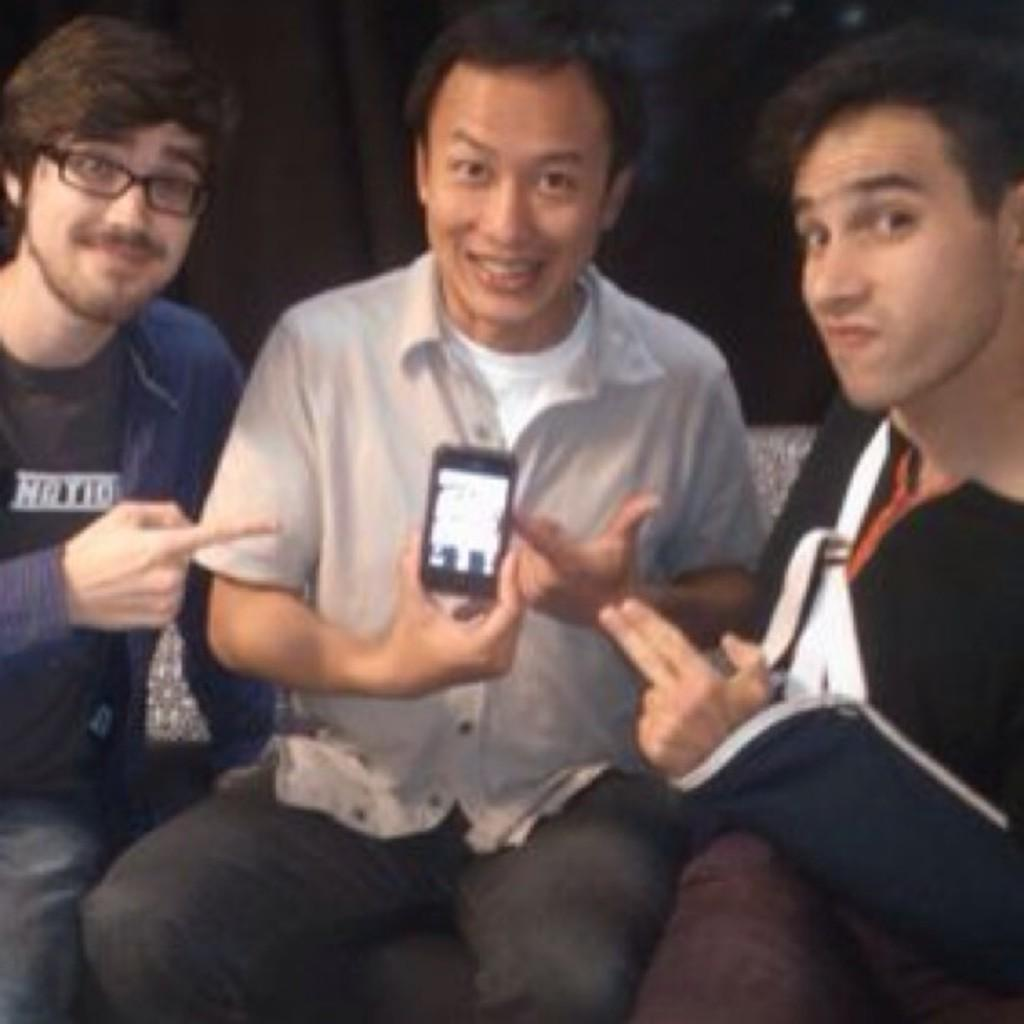How many people are in the image? There are three persons in the image. What are the persons doing in the image? The persons are sitting on a chair and smiling. Can you describe the appearance of the left person? The left person is wearing spectacles and holding a mobile phone. What word is the person on the right saying in the image? There is no indication in the image of what words the persons might be saying, as their mouths are not visible. --- Facts: 1. There is a car in the image. 2. The car is red. 3. The car has four wheels. 4. There is a road in the image. 5. The road is paved. Absurd Topics: bird, dance, ocean Conversation: What is the main subject of the image? The main subject of the image is a car. Can you describe the appearance of the car? The car is red and has four wheels. What is the surface of the road in the image? The road is paved. Reasoning: Let's think step by step in order to produce the conversation. We start by identifying the main subject of the image, which is the car. Then, we describe its appearance, noting that it is red and has four wheels. Finally, we focus on the road in the image, mentioning that it is paved. Absurd Question/Answer: Can you see any birds dancing in the ocean in the image? There is no bird, dance, or ocean present in the image; it features a red car on a paved road. 